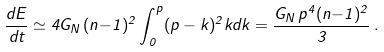<formula> <loc_0><loc_0><loc_500><loc_500>\frac { d E } { d t } \simeq 4 G _ { N } \, ( n { - } 1 ) ^ { 2 } \int _ { 0 } ^ { p } ( p - k ) ^ { 2 } k d k = \frac { G _ { N } \, p ^ { 4 } ( n { - } 1 ) ^ { 2 } } { 3 } \, .</formula> 